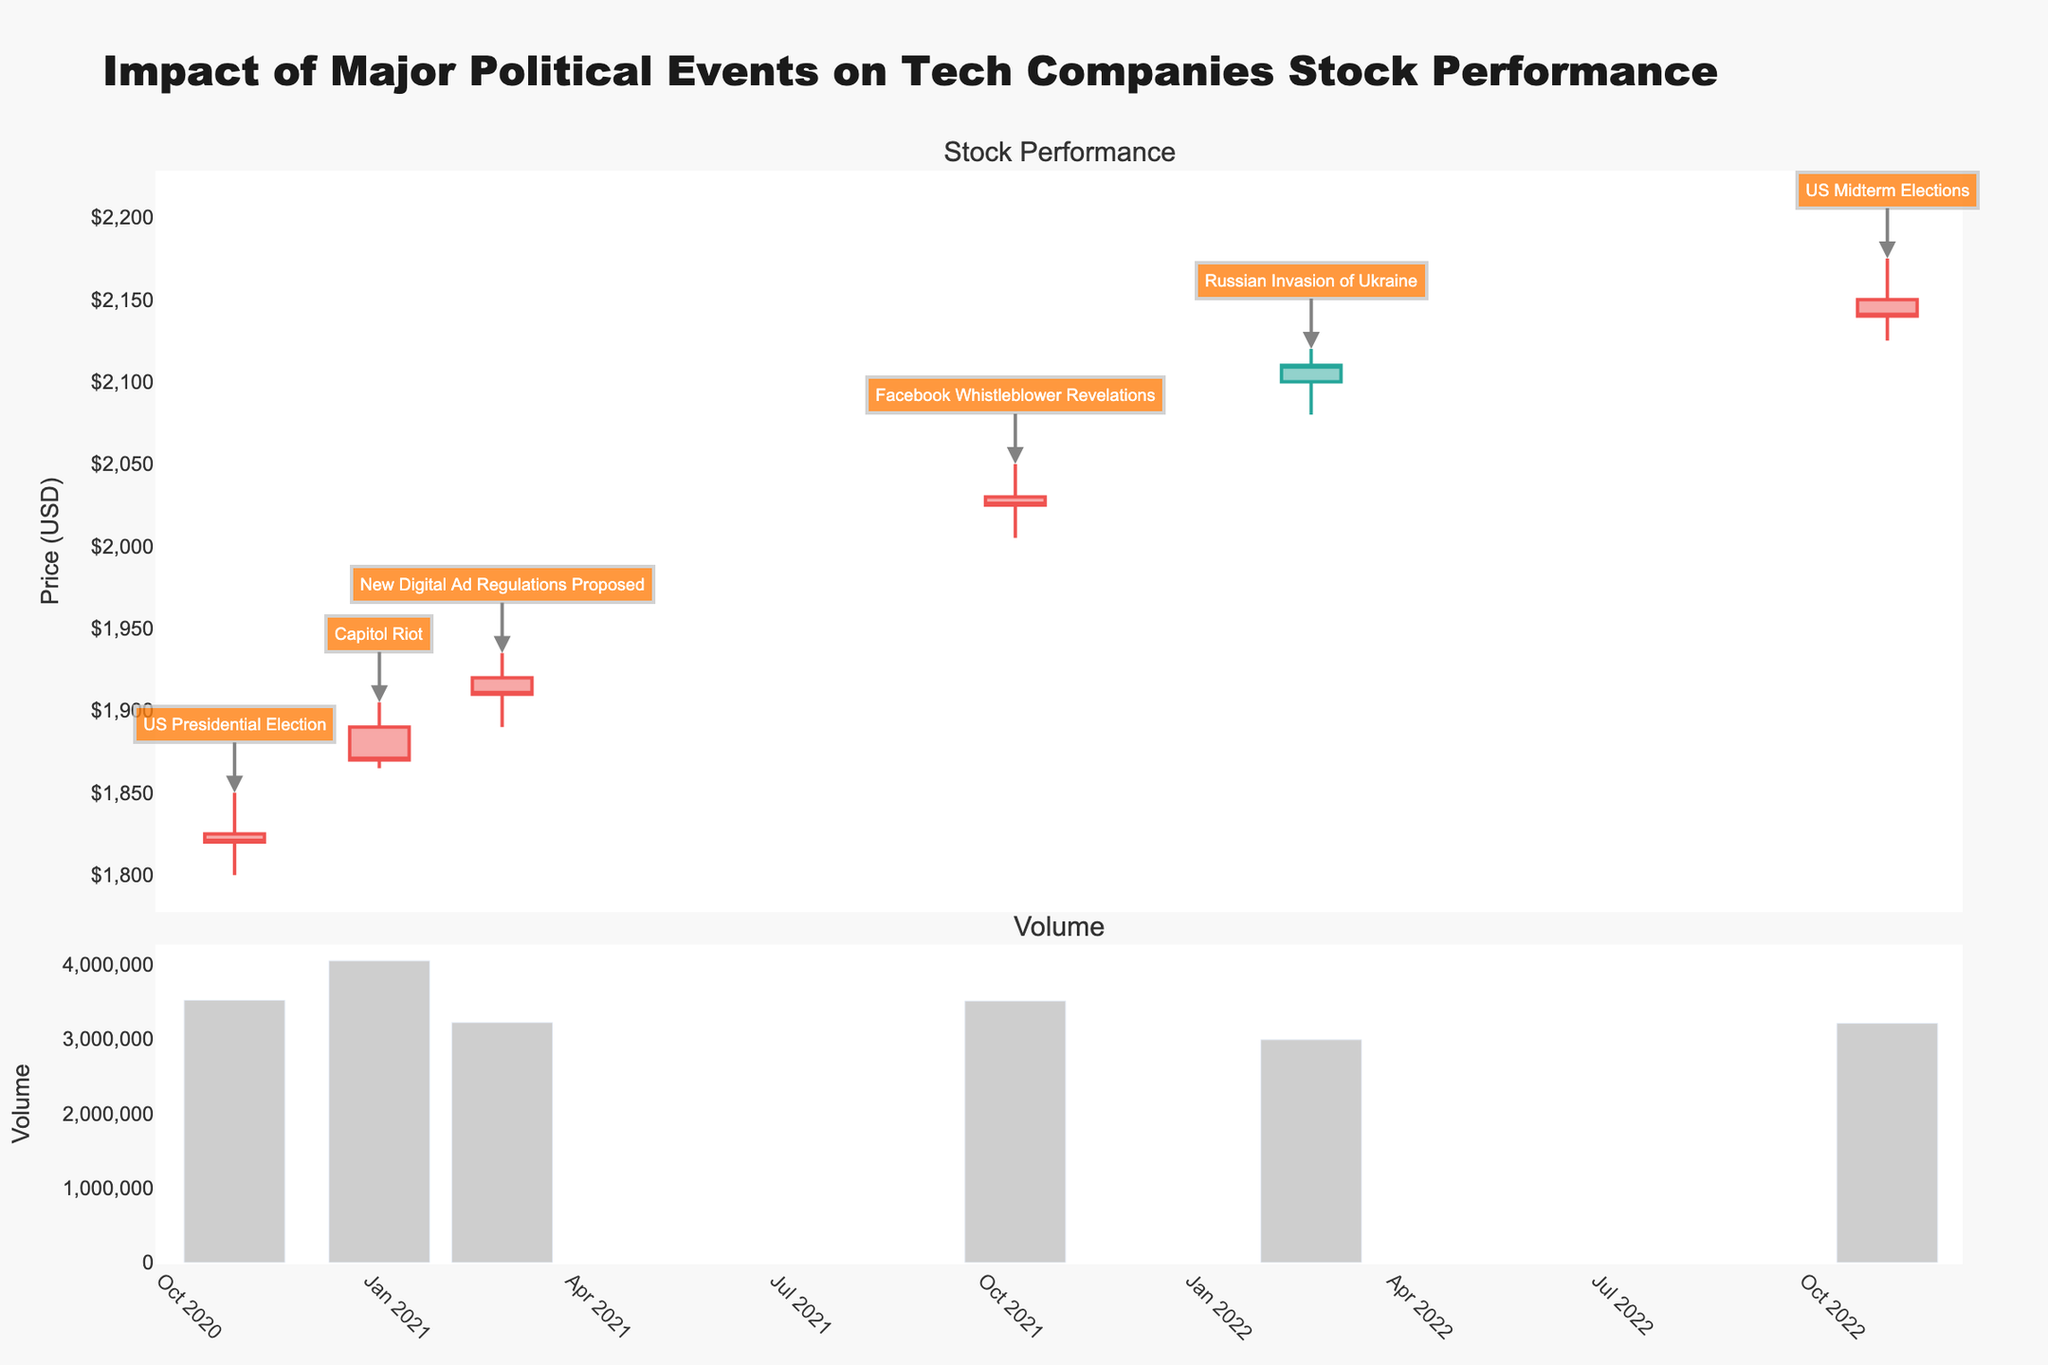What is the title of the chart? The title of the chart is clearly displayed at the top of the figure. It reads "Impact of Major Political Events on Tech Companies Stock Performance."
Answer: Impact of Major Political Events on Tech Companies Stock Performance Which event caused the highest stock price increase according to the candlestick plot? The Facebook Whistleblower Revelations event shows the highest difference between the open and high prices. The stock opened at $2030 and the highest price during that day was $2050.
Answer: Facebook Whistleblower Revelations What is the closing price on the day of the US Presidential Election? To find the closing price, look at the candlestick corresponding to the date of the US Presidential Election. The closing price is at the lower end of the thick part of the candlestick.
Answer: $1820 How does the stock volume on the day of the Capitol Riot compare to the stock volume on the day of the New Digital Ad Regulations Proposed? Compare the height of the bars in the volume subplot for January 6, 2021 (Capitol Riot) and March 2, 2021 (New Digital Ad Regulations Proposed). The bar on January 6 is taller than the one on March 2, indicating higher volume.
Answer: Higher on Capitol Riot What was the range (difference between high and low prices) on the day of the Russian Invasion of Ukraine? To find the range, subtract the low price from the high price on February 24, 2022. The high is $2120 and the low is $2080, so the range is $2120 - $2080.
Answer: $40 How many significant political events are annotated on the candlestick plot? Count the number of annotations (text labels with arrows pointing to the candlesticks) on the plot. There are six annotated events.
Answer: 6 What is the trend in stock price for tech companies involved in digital advertising from the US Presidential Election in 2020 to the US Midterm Elections in 2022? Observe the direction of the candlesticks from November 3, 2020, to November 8, 2022. The general trend shows an increase in the closing prices over this period.
Answer: Increasing Which event corresponds to the highest trading volume? Examine the heights of the bars in the volume subplot. The tallest bar represents the highest volume, which occurred on January 6, 2021 (Capitol Riot).
Answer: Capitol Riot What was the lowest stock price on the day of New Digital Ad Regulations Proposed? To find the lowest price, look at the bottom of the thin line (wick) of the candlestick on March 2, 2021. The lowest price is $1890.
Answer: $1890 